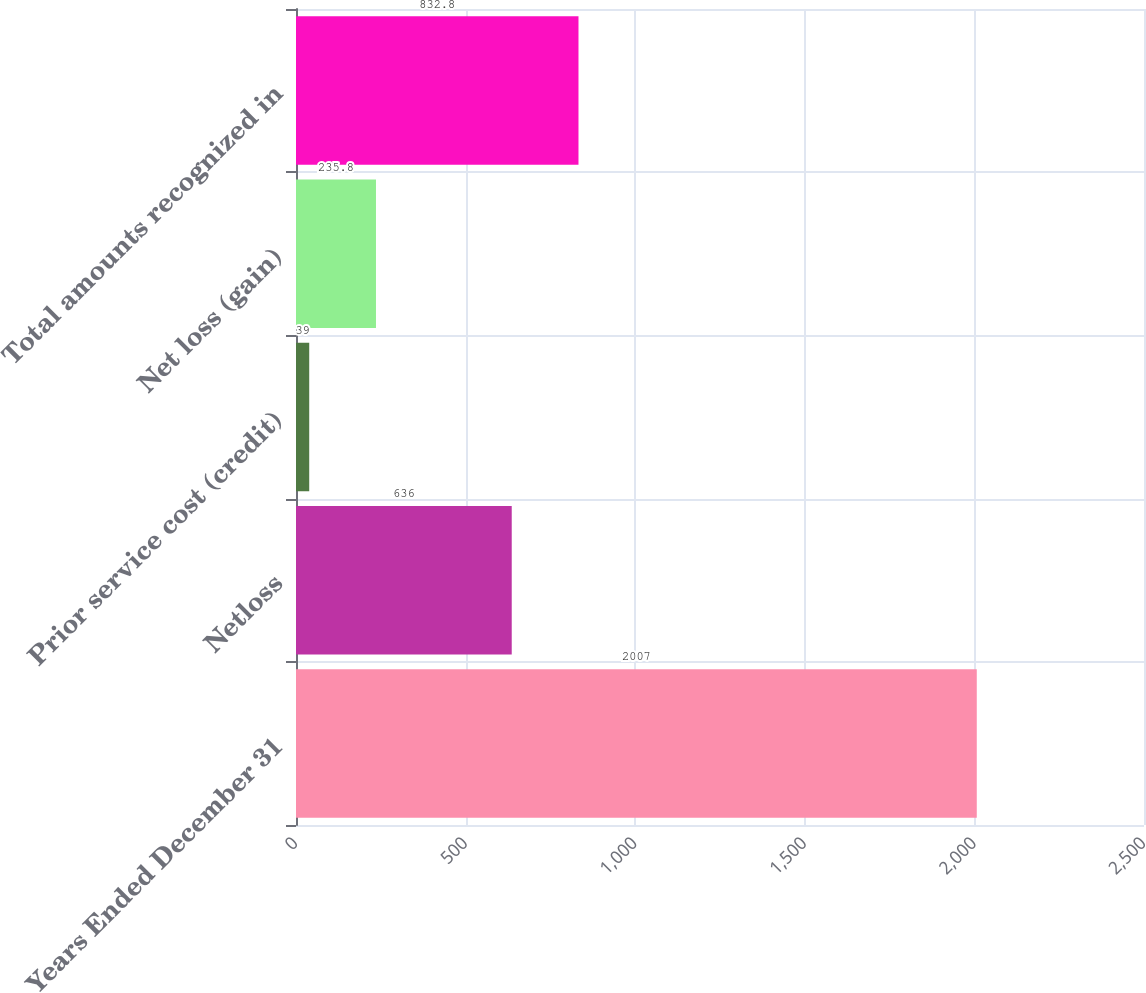Convert chart. <chart><loc_0><loc_0><loc_500><loc_500><bar_chart><fcel>Years Ended December 31<fcel>Netloss<fcel>Prior service cost (credit)<fcel>Net loss (gain)<fcel>Total amounts recognized in<nl><fcel>2007<fcel>636<fcel>39<fcel>235.8<fcel>832.8<nl></chart> 